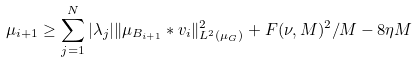<formula> <loc_0><loc_0><loc_500><loc_500>\mu _ { i + 1 } \geq \sum _ { j = 1 } ^ { N } { | \lambda _ { j } | \| \mu _ { B _ { i + 1 } } \ast v _ { i } \| _ { L ^ { 2 } ( \mu _ { G } ) } ^ { 2 } } + F ( \nu , M ) ^ { 2 } / M - 8 \eta M</formula> 